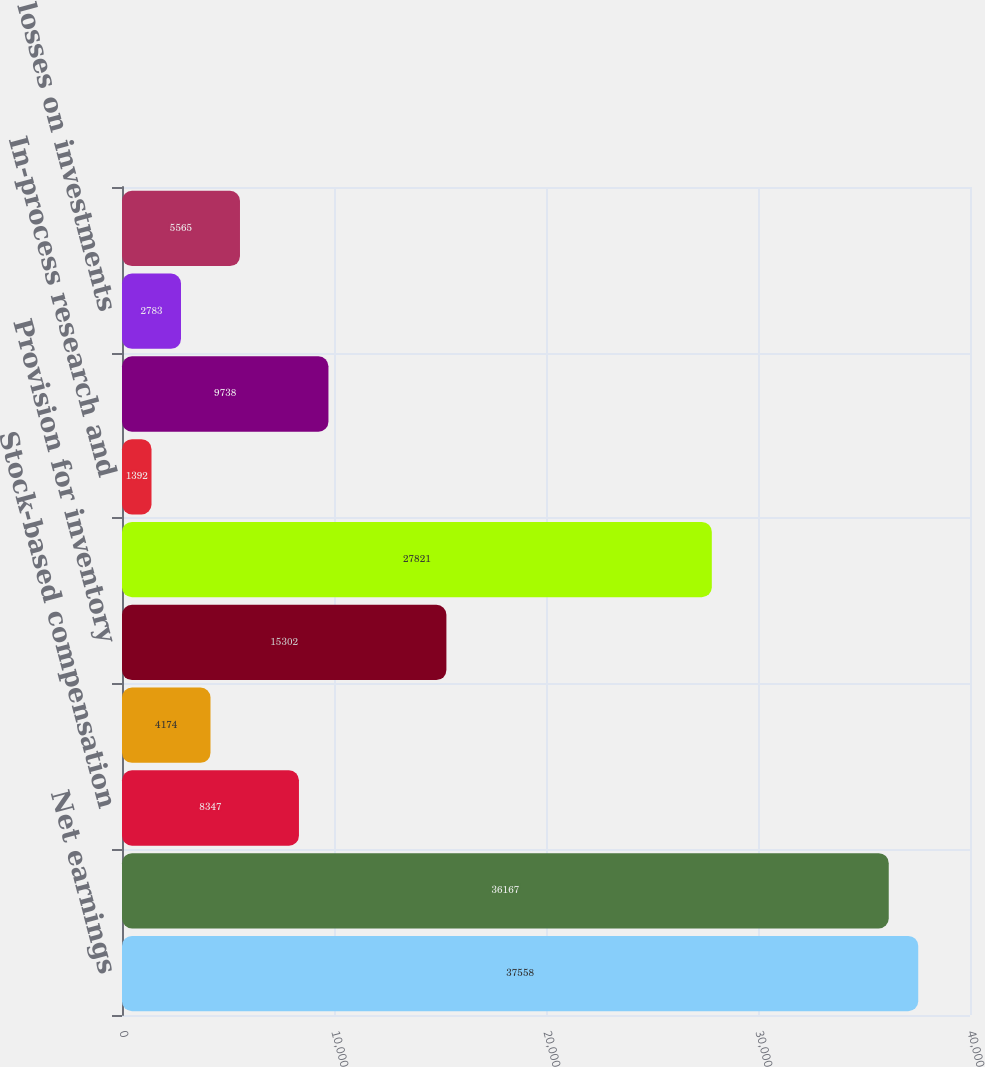Convert chart. <chart><loc_0><loc_0><loc_500><loc_500><bar_chart><fcel>Net earnings<fcel>Depreciation and amortization<fcel>Stock-based compensation<fcel>Provision (benefit) for<fcel>Provision for inventory<fcel>Restructuring charges<fcel>In-process research and<fcel>Deferred taxes on earnings<fcel>(Gains) losses on investments<fcel>Other net<nl><fcel>37558<fcel>36167<fcel>8347<fcel>4174<fcel>15302<fcel>27821<fcel>1392<fcel>9738<fcel>2783<fcel>5565<nl></chart> 